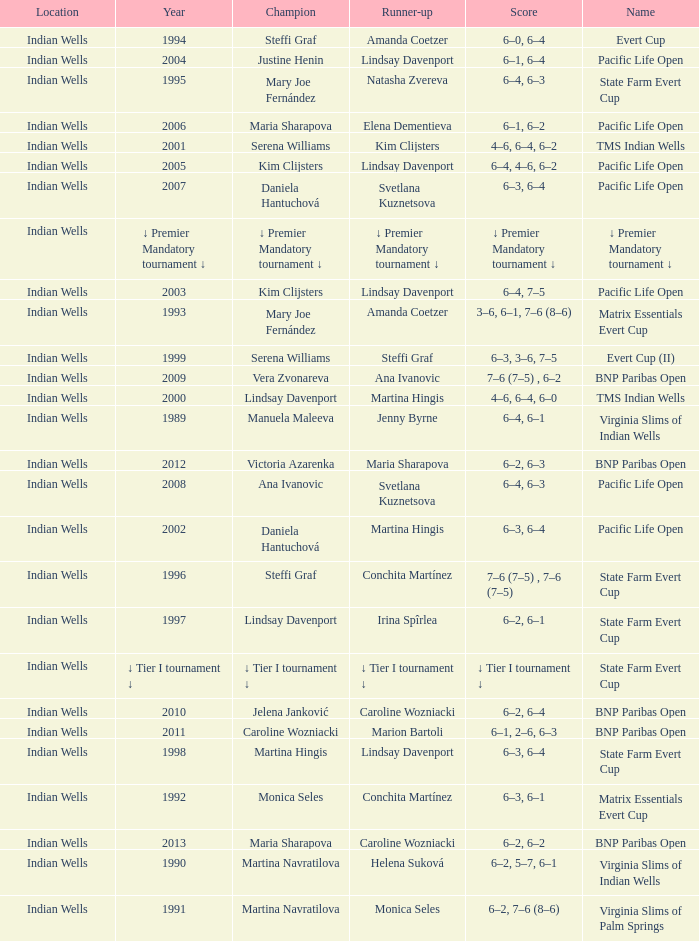Who was runner-up in the 2006 Pacific Life Open? Elena Dementieva. 